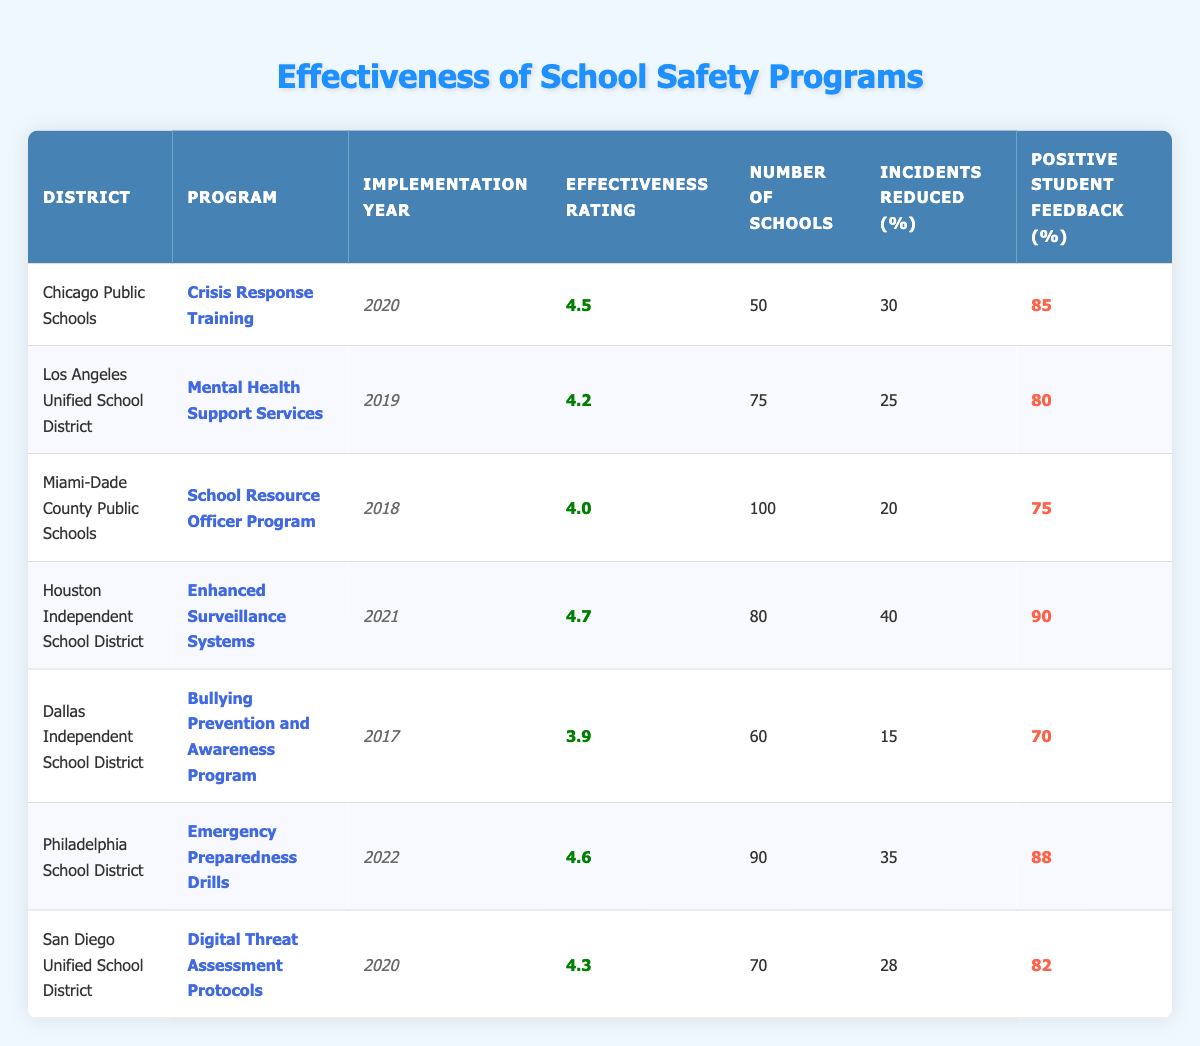What is the effectiveness rating of the "Crisis Response Training" program? The table lists the effectiveness rating for the "Crisis Response Training" program under the "Effectiveness Rating" column for the Chicago Public Schools district. That value is 4.5.
Answer: 4.5 Which district has the highest effectiveness rating for a school safety program? By comparing the effectiveness ratings in the table, the "Enhanced Surveillance Systems" program in the Houston Independent School District has the highest rating of 4.7.
Answer: Houston Independent School District How many schools implemented the "Mental Health Support Services" program? The number of schools implementing the "Mental Health Support Services" program is found in the corresponding row under the "Number of Schools" column, which is 75.
Answer: 75 What is the average effectiveness rating of all the programs listed in the table? To calculate the average, add up all effectiveness ratings: (4.5 + 4.2 + 4.0 + 4.7 + 3.9 + 4.6 + 4.3) = 30.2. Then divide by the number of programs (7): 30.2 / 7 = approximately 4.314.
Answer: 4.31 How many reported incidents were reduced by the "School Resource Officer Program"? The table shows the number of reported incidents reduced by the "School Resource Officer Program" in the corresponding row, which is 20.
Answer: 20 Does the "Bullying Prevention and Awareness Program" have a positive student feedback rate of 75% or higher? The positive student feedback for this program is listed as 70% in the table, which is lower than 75%. Therefore, the answer is no.
Answer: No Which program has the second highest positive student feedback percentage? The student feedback percentages are sorted as follows: Enhanced Surveillance Systems (90%), Emergency Preparedness Drills (88%), Crisis Response Training (85%), followed by Digital Threat Assessment Protocols (82%). The second highest is Emergency Preparedness Drills with 88%.
Answer: Emergency Preparedness Drills How many total incident reductions are reported across all programs? The total incident reductions can be calculated by adding the reported incidents reduced of all programs: 30 + 25 + 20 + 40 + 15 + 35 + 28 = 193.
Answer: 193 Which program was implemented first and what is its effectiveness rating? By checking the implementation years in the table, the "Bullying Prevention and Awareness Program" was implemented first in 2017, and its effectiveness rating is 3.9.
Answer: 3.9 Is there a program with an effectiveness rating below 4.0? Yes, according to the table, the "Bullying Prevention and Awareness Program" has an effectiveness rating of 3.9, which is below 4.0.
Answer: Yes 